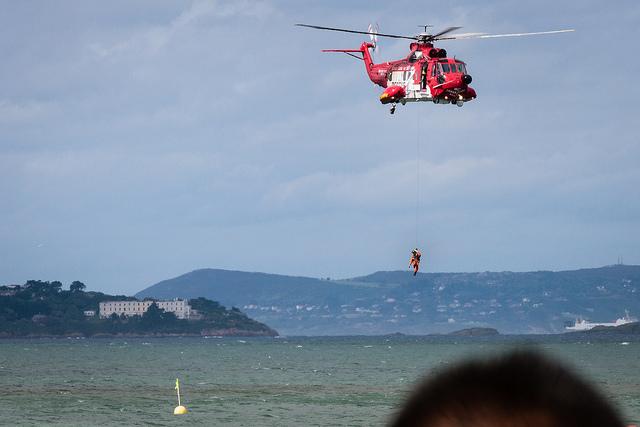What kind of helicopter is this?
Be succinct. Rescue. Is this a rescue mission?
Keep it brief. Yes. Is there a person getting out of the helicopter?
Keep it brief. Yes. 